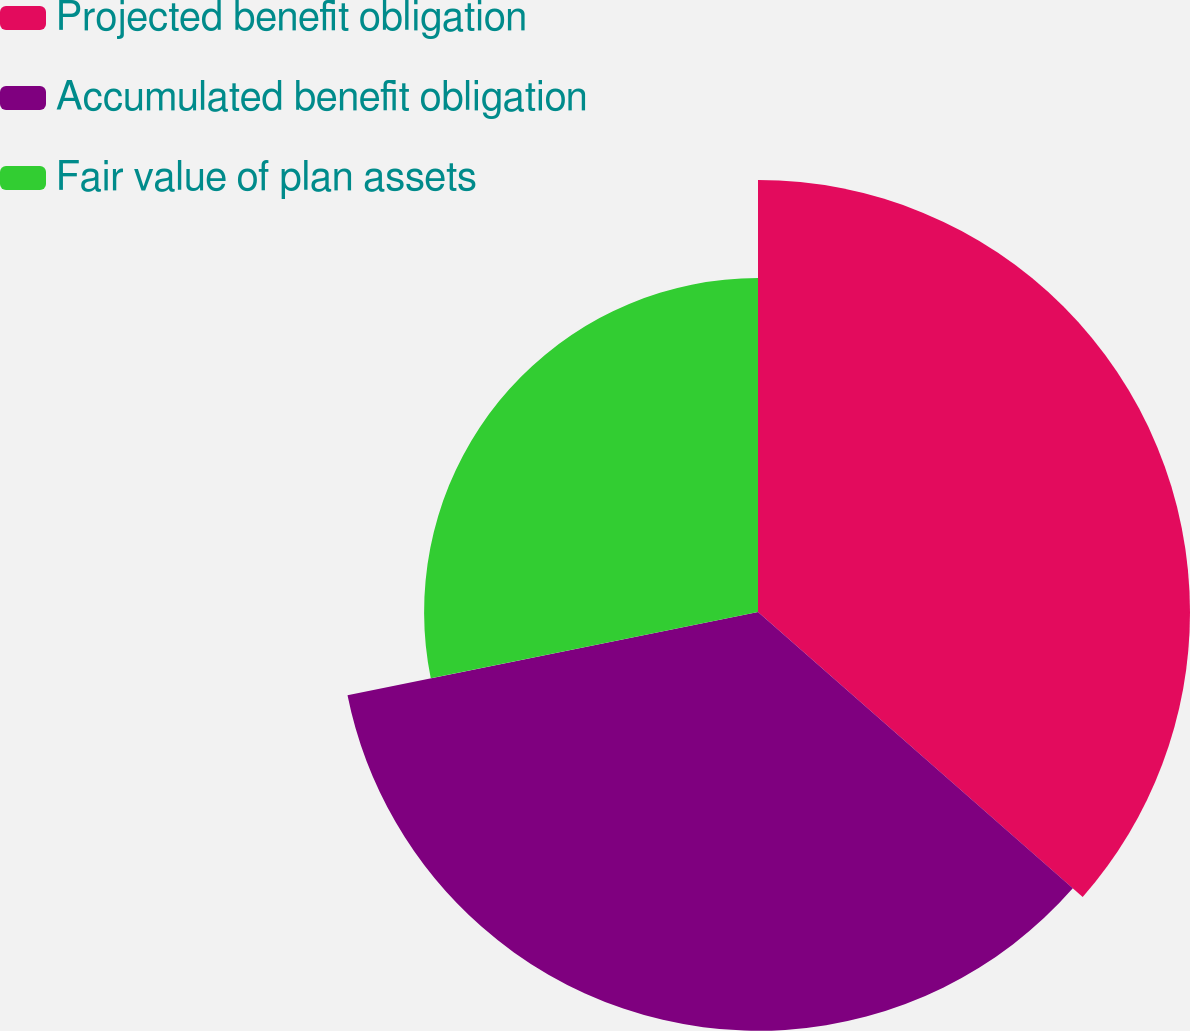Convert chart. <chart><loc_0><loc_0><loc_500><loc_500><pie_chart><fcel>Projected benefit obligation<fcel>Accumulated benefit obligation<fcel>Fair value of plan assets<nl><fcel>36.46%<fcel>35.35%<fcel>28.18%<nl></chart> 